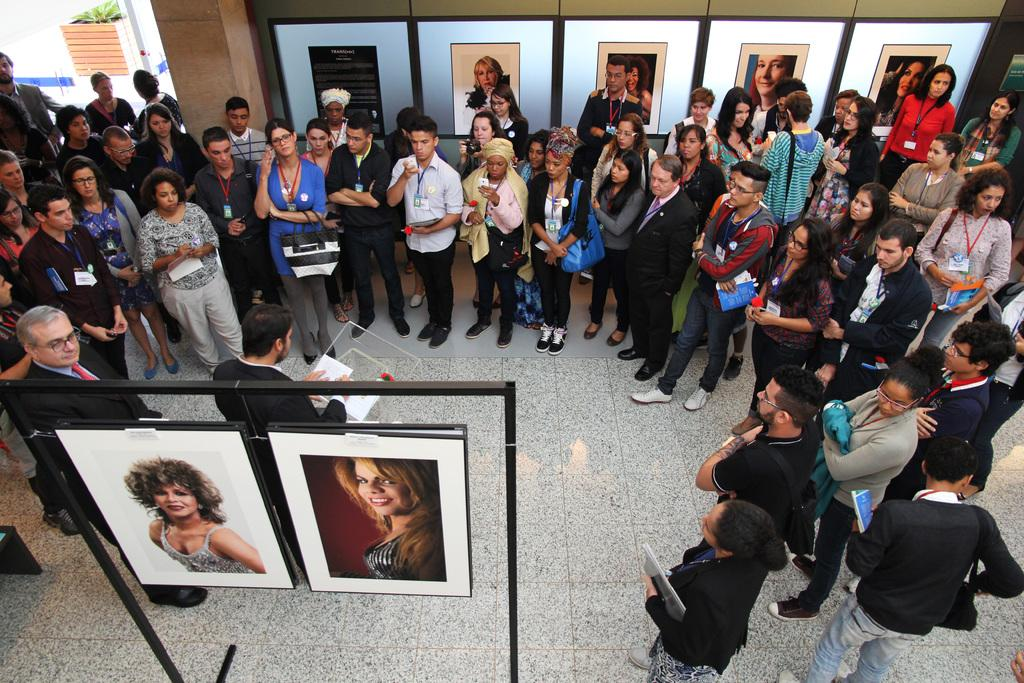What is the person in the image wearing? The person is wearing a black suit in the image. What is the person doing in the image? The person is standing in the image. What is the person holding in the image? The person is holding a paper in his hands. What can be seen behind the person in the image? There are two photo frames behind the person in the image. What is happening in front of the person in the image? There are people standing in front of the person in the image. How many pages are visible in the image? There are no pages visible in the image. --- Facts: 1. There is a person in the image. 2. The person is sitting on a chair. 3. The person is holding a book. 4. The book is open. 5. The chair is made of wood. 6. The person is wearing glasses. Absurd Topics: parrot, bicycle, ocean Conversation: What is the main subject in the image? The main subject in the image is a person. What is the person doing in the image? The person is sitting on a chair in the image. What is the person holding in the image? The person is holding a book in the image. What is the condition of the book in the image? The book is open in the image. What is the chair made of in the image? The chair is made of wood in the image. What is the person wearing in the image? The person is wearing glasses in the image. Reasoning: Let's think step by step in order to produce the conversation. We start by identifying the main subject of the image, which is a person. Next, we describe the person's actions, noting that they are sitting on a chair. Then, we observe the object the person is holding, which is a book. We also describe the chair's material, which is wood. Finally, we mention the person's accessory, which are glasses. Absurd Question/Answer: Can you see a parrot riding a bicycle near the ocean in the image? There is no parrot, bicycle, or ocean present in the image. 